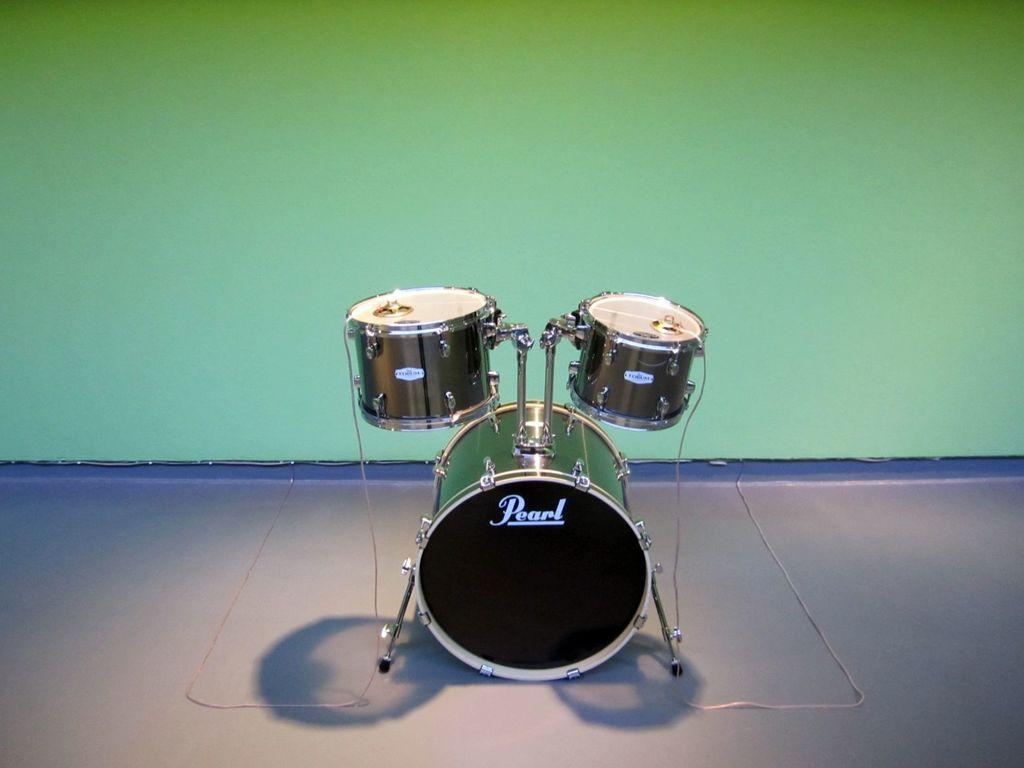Can you describe this image briefly? In this image I can see drums. The background is green in color. 